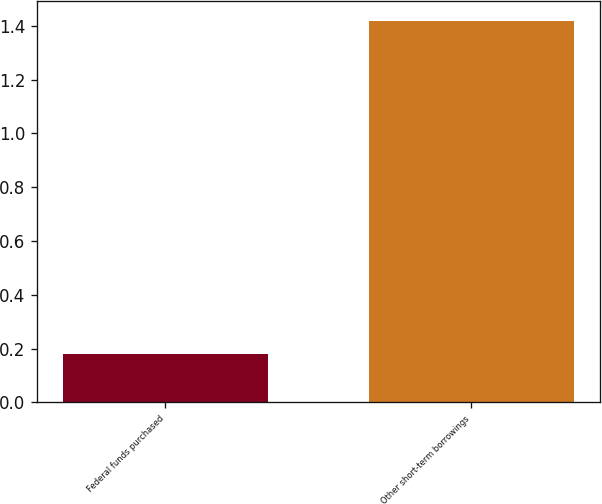<chart> <loc_0><loc_0><loc_500><loc_500><bar_chart><fcel>Federal funds purchased<fcel>Other short-term borrowings<nl><fcel>0.18<fcel>1.42<nl></chart> 